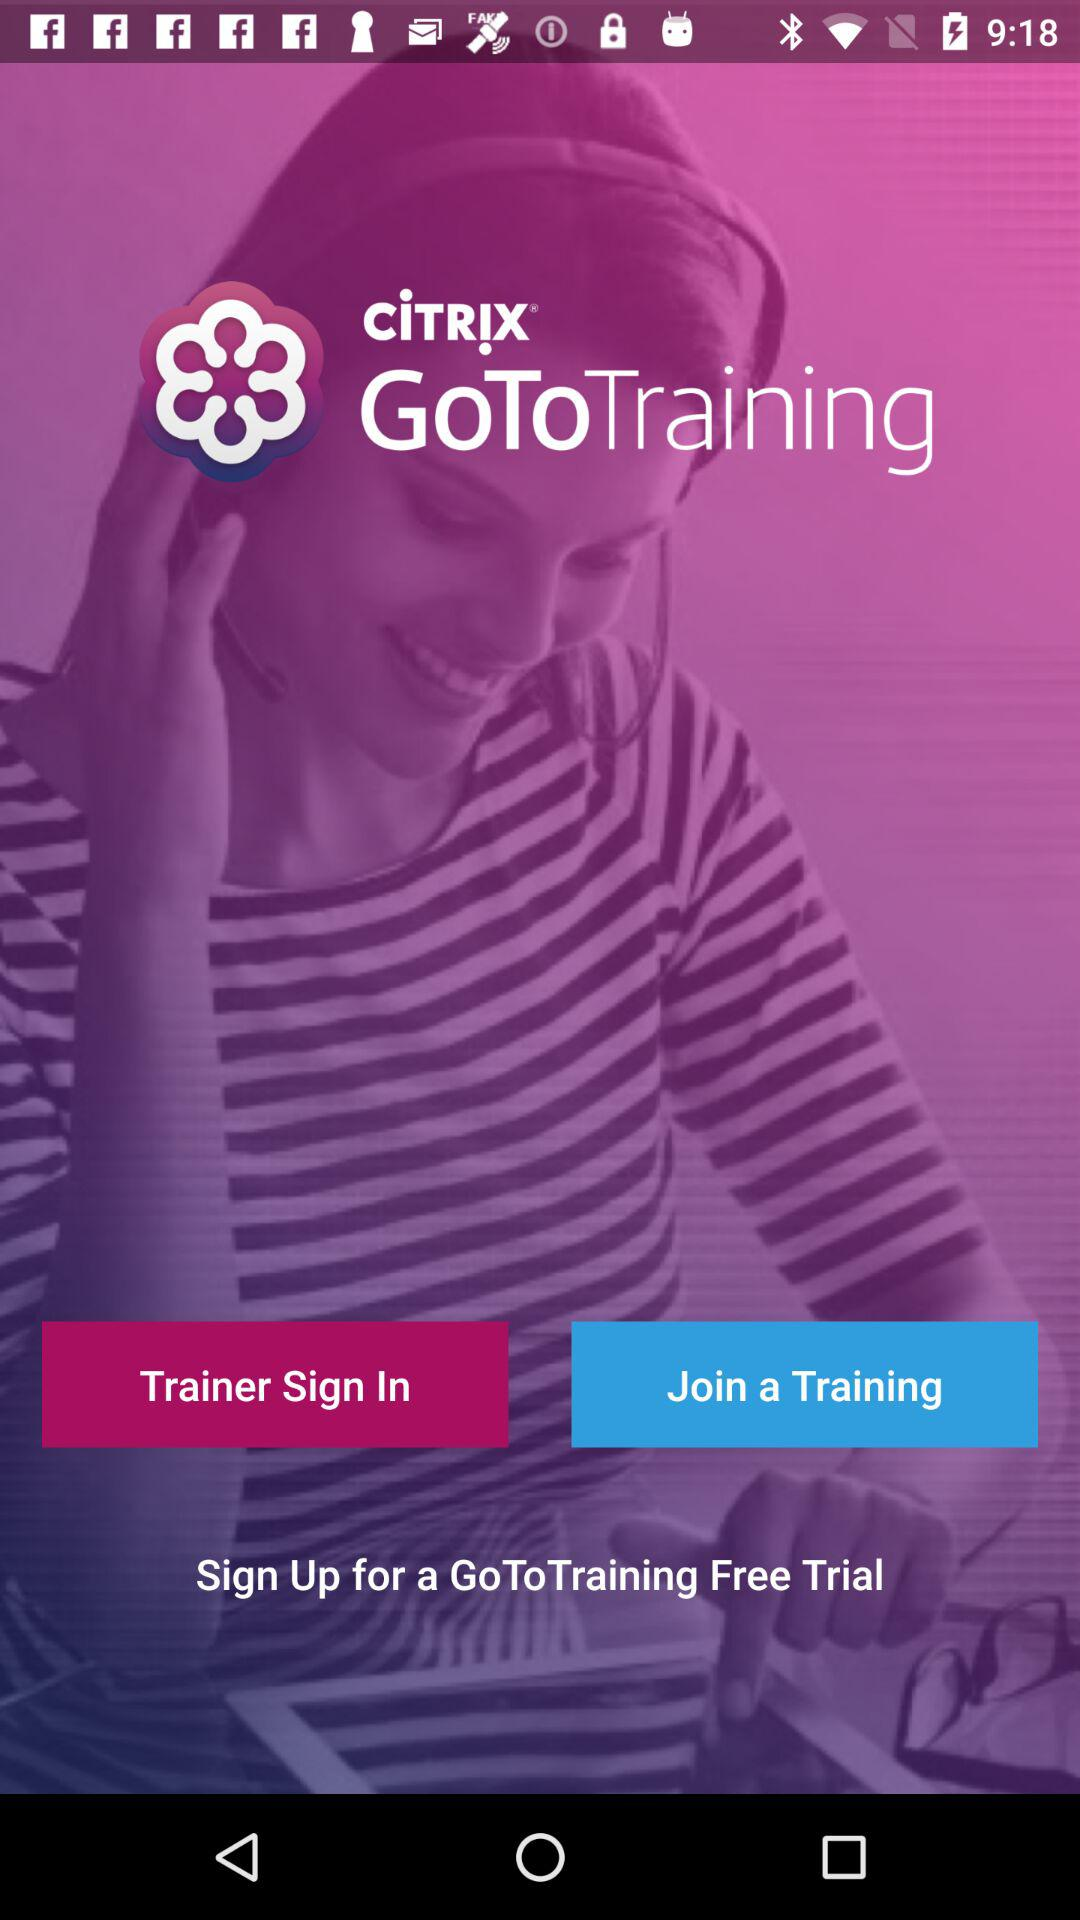What is the name of the application? The name of the application is "CiTRiX GoToTraining". 